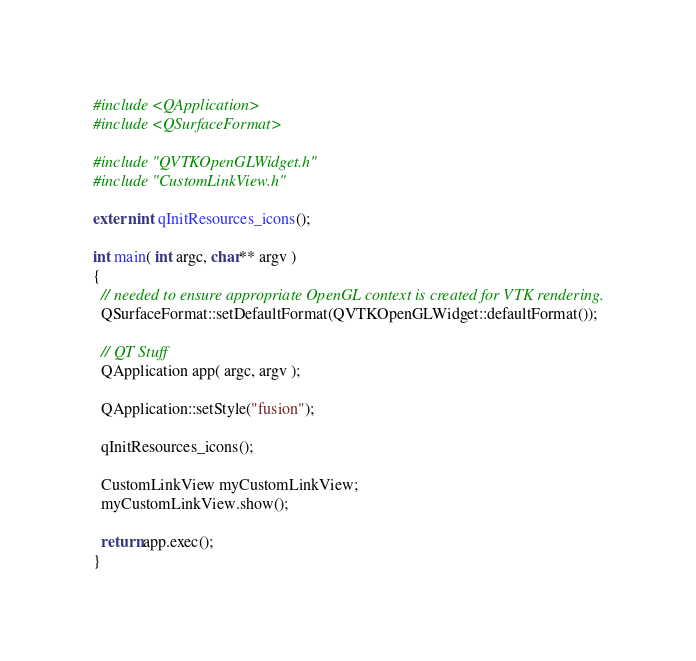<code> <loc_0><loc_0><loc_500><loc_500><_C++_>#include <QApplication>
#include <QSurfaceFormat>

#include "QVTKOpenGLWidget.h"
#include "CustomLinkView.h"

extern int qInitResources_icons();

int main( int argc, char** argv )
{
  // needed to ensure appropriate OpenGL context is created for VTK rendering.
  QSurfaceFormat::setDefaultFormat(QVTKOpenGLWidget::defaultFormat());

  // QT Stuff
  QApplication app( argc, argv );

  QApplication::setStyle("fusion");

  qInitResources_icons();

  CustomLinkView myCustomLinkView;
  myCustomLinkView.show();

  return app.exec();
}
</code> 